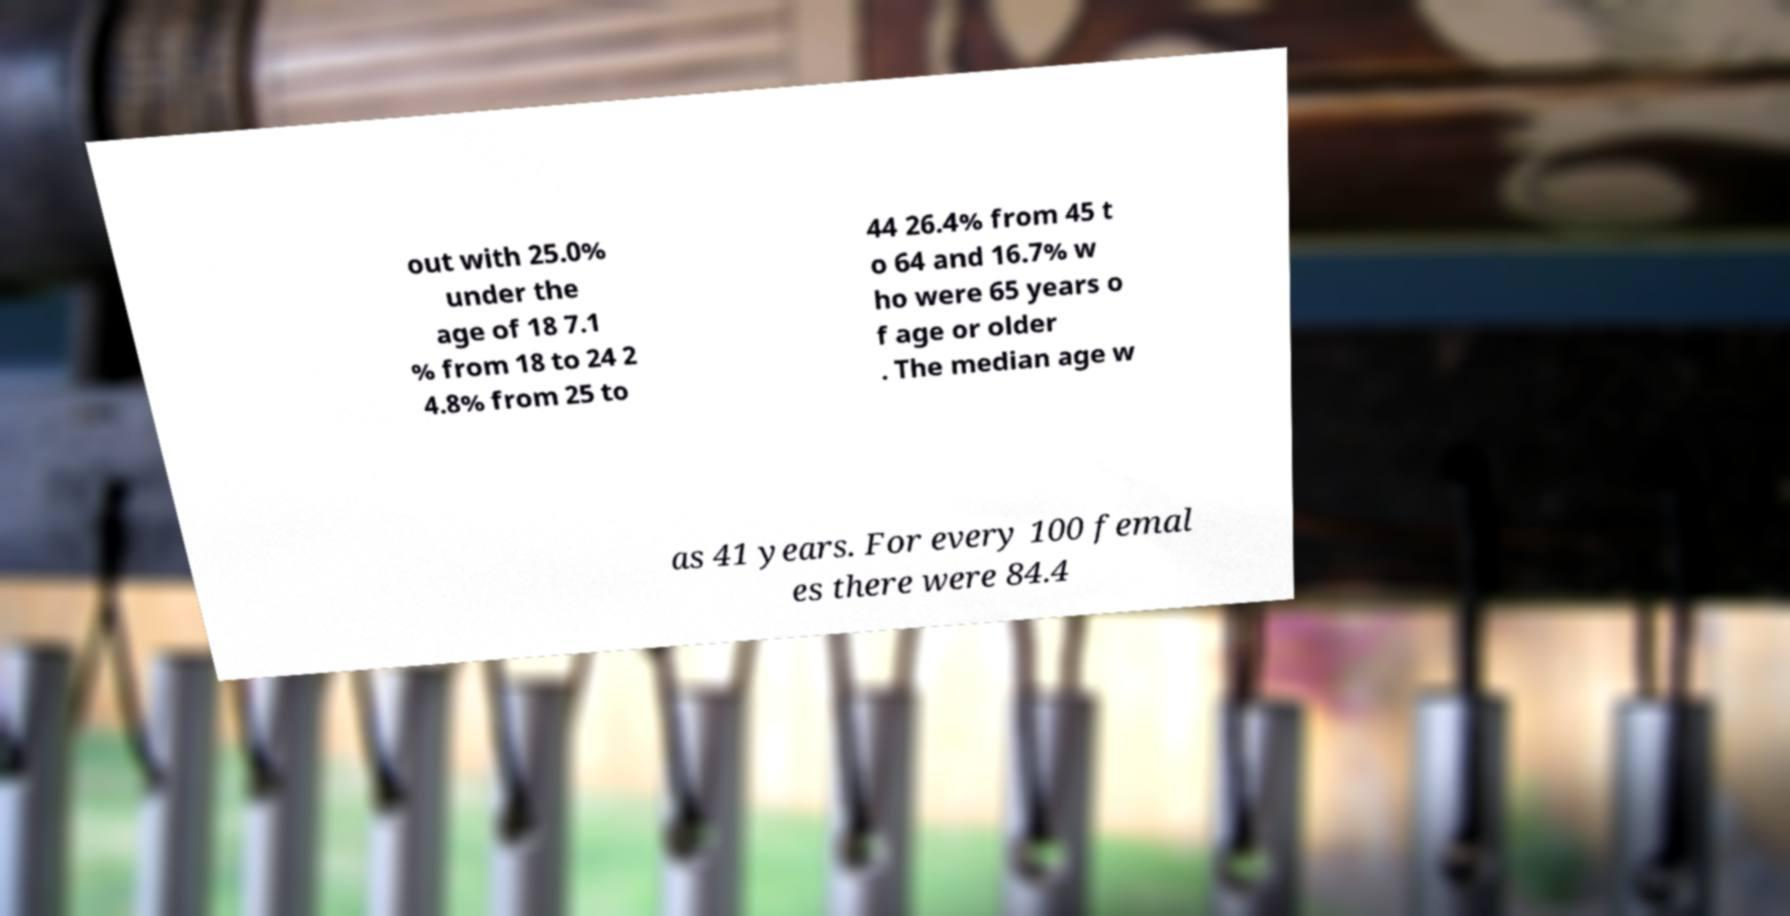Could you assist in decoding the text presented in this image and type it out clearly? out with 25.0% under the age of 18 7.1 % from 18 to 24 2 4.8% from 25 to 44 26.4% from 45 t o 64 and 16.7% w ho were 65 years o f age or older . The median age w as 41 years. For every 100 femal es there were 84.4 